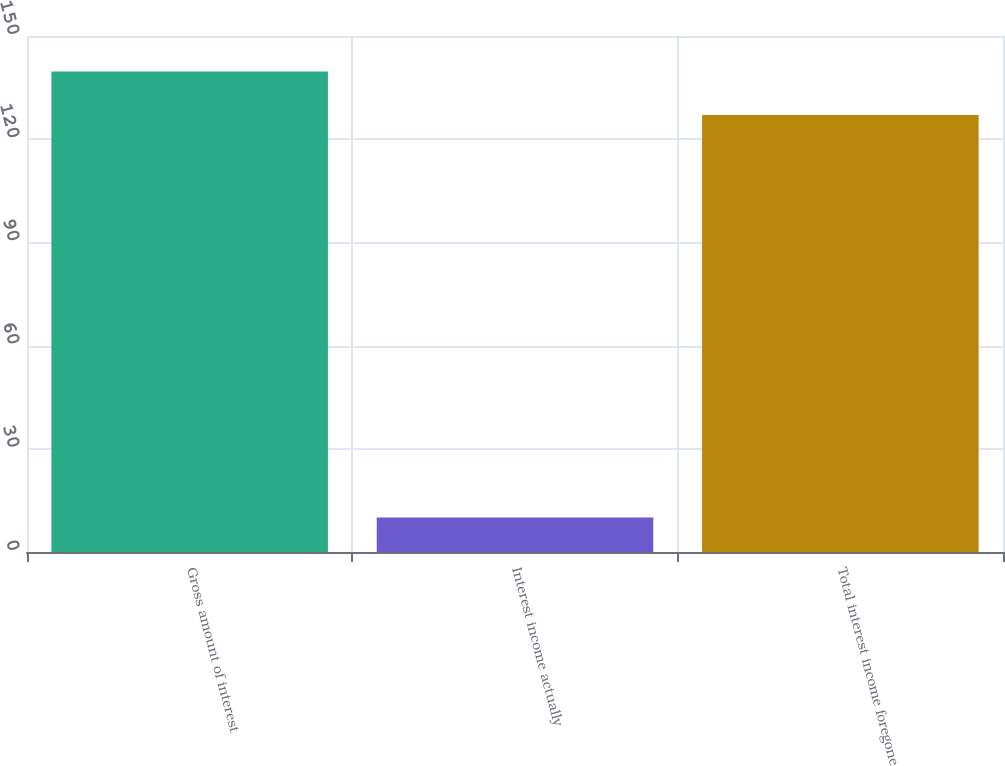Convert chart to OTSL. <chart><loc_0><loc_0><loc_500><loc_500><bar_chart><fcel>Gross amount of interest<fcel>Interest income actually<fcel>Total interest income foregone<nl><fcel>139.7<fcel>10<fcel>127<nl></chart> 